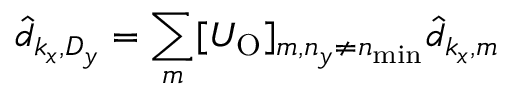Convert formula to latex. <formula><loc_0><loc_0><loc_500><loc_500>\hat { d } _ { k _ { x } , D _ { y } } = \sum _ { m } [ U _ { O } ] _ { m , n _ { y } \ne n _ { \min } } \hat { d } _ { k _ { x } , m }</formula> 